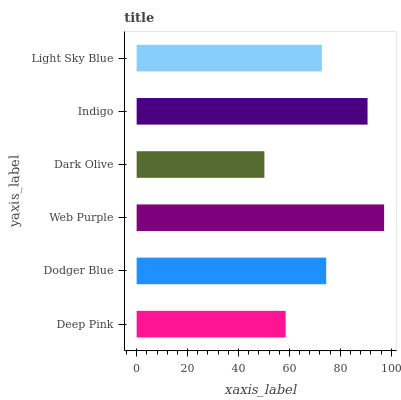Is Dark Olive the minimum?
Answer yes or no. Yes. Is Web Purple the maximum?
Answer yes or no. Yes. Is Dodger Blue the minimum?
Answer yes or no. No. Is Dodger Blue the maximum?
Answer yes or no. No. Is Dodger Blue greater than Deep Pink?
Answer yes or no. Yes. Is Deep Pink less than Dodger Blue?
Answer yes or no. Yes. Is Deep Pink greater than Dodger Blue?
Answer yes or no. No. Is Dodger Blue less than Deep Pink?
Answer yes or no. No. Is Dodger Blue the high median?
Answer yes or no. Yes. Is Light Sky Blue the low median?
Answer yes or no. Yes. Is Light Sky Blue the high median?
Answer yes or no. No. Is Web Purple the low median?
Answer yes or no. No. 